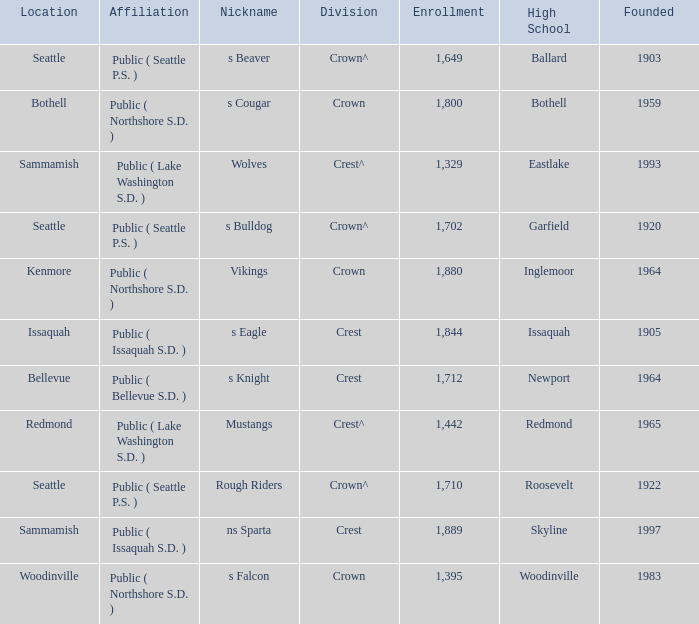What High School with a nickname of S Eagle has a Division of crest? Issaquah. 